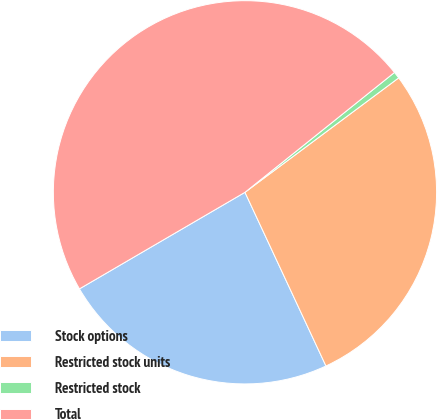Convert chart to OTSL. <chart><loc_0><loc_0><loc_500><loc_500><pie_chart><fcel>Stock options<fcel>Restricted stock units<fcel>Restricted stock<fcel>Total<nl><fcel>23.54%<fcel>28.24%<fcel>0.57%<fcel>47.65%<nl></chart> 